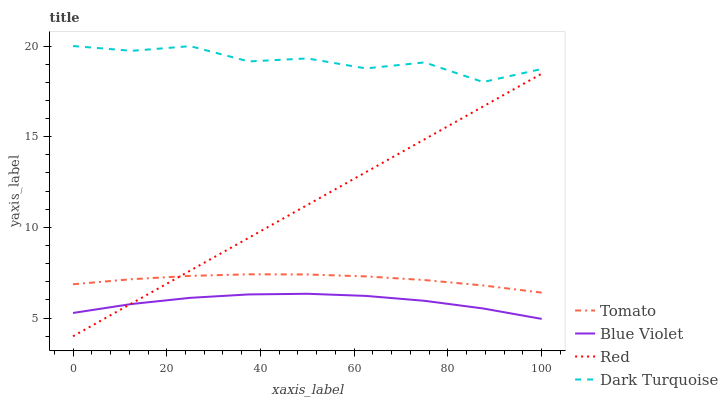Does Blue Violet have the minimum area under the curve?
Answer yes or no. Yes. Does Dark Turquoise have the maximum area under the curve?
Answer yes or no. Yes. Does Red have the minimum area under the curve?
Answer yes or no. No. Does Red have the maximum area under the curve?
Answer yes or no. No. Is Red the smoothest?
Answer yes or no. Yes. Is Dark Turquoise the roughest?
Answer yes or no. Yes. Is Dark Turquoise the smoothest?
Answer yes or no. No. Is Red the roughest?
Answer yes or no. No. Does Red have the lowest value?
Answer yes or no. Yes. Does Dark Turquoise have the lowest value?
Answer yes or no. No. Does Dark Turquoise have the highest value?
Answer yes or no. Yes. Does Red have the highest value?
Answer yes or no. No. Is Blue Violet less than Dark Turquoise?
Answer yes or no. Yes. Is Dark Turquoise greater than Tomato?
Answer yes or no. Yes. Does Blue Violet intersect Red?
Answer yes or no. Yes. Is Blue Violet less than Red?
Answer yes or no. No. Is Blue Violet greater than Red?
Answer yes or no. No. Does Blue Violet intersect Dark Turquoise?
Answer yes or no. No. 